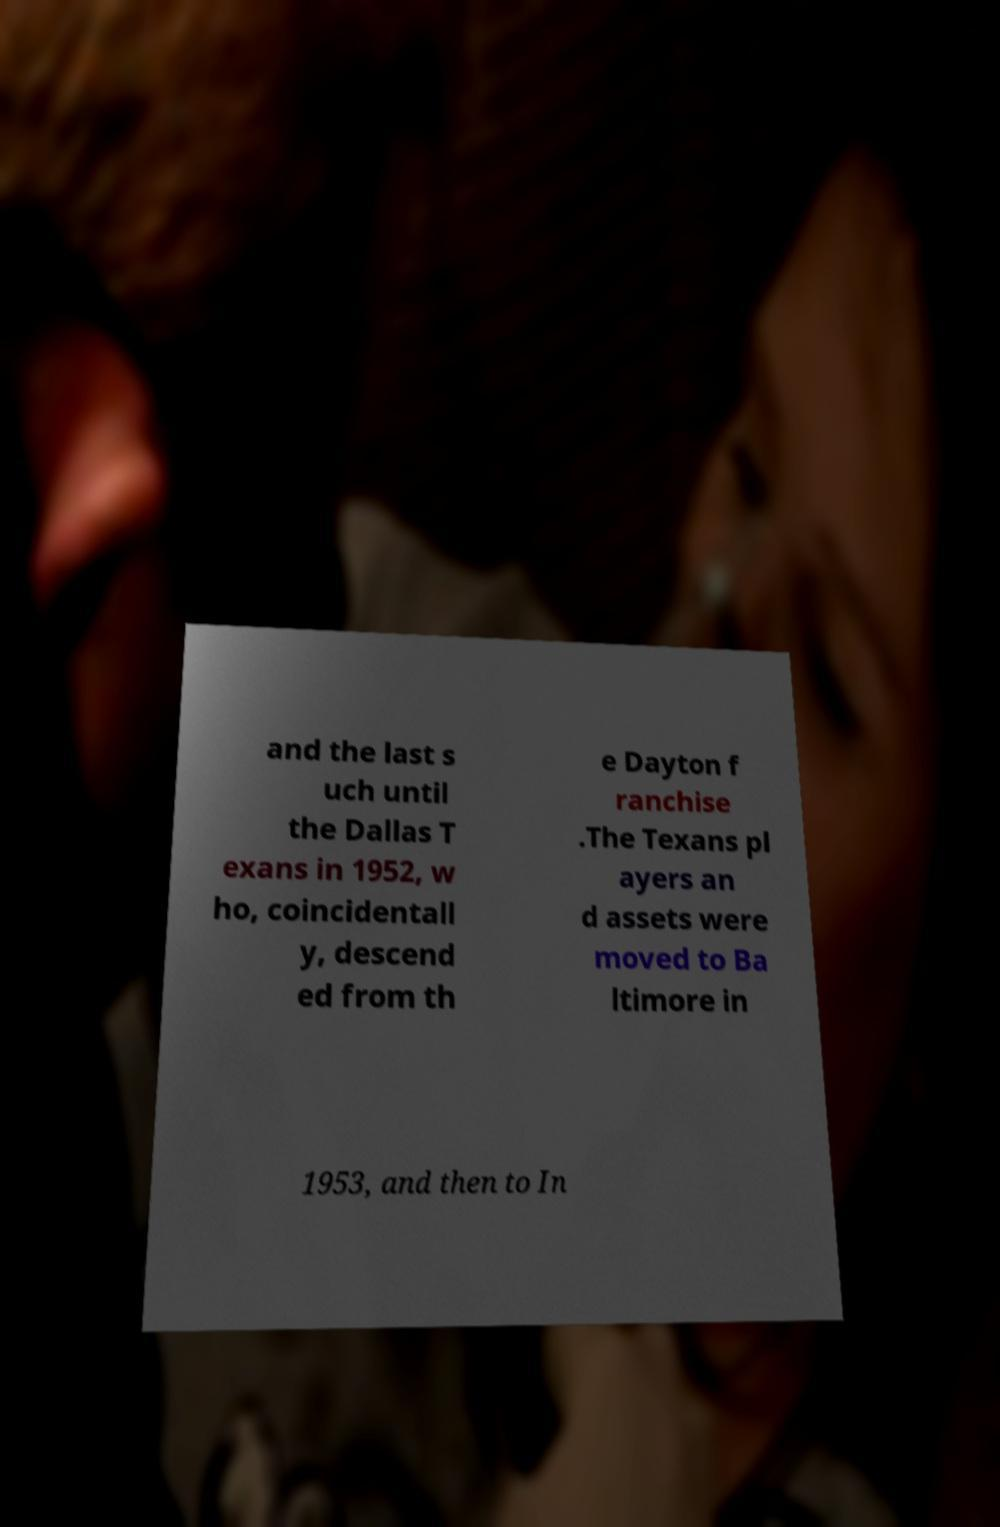Please read and relay the text visible in this image. What does it say? and the last s uch until the Dallas T exans in 1952, w ho, coincidentall y, descend ed from th e Dayton f ranchise .The Texans pl ayers an d assets were moved to Ba ltimore in 1953, and then to In 